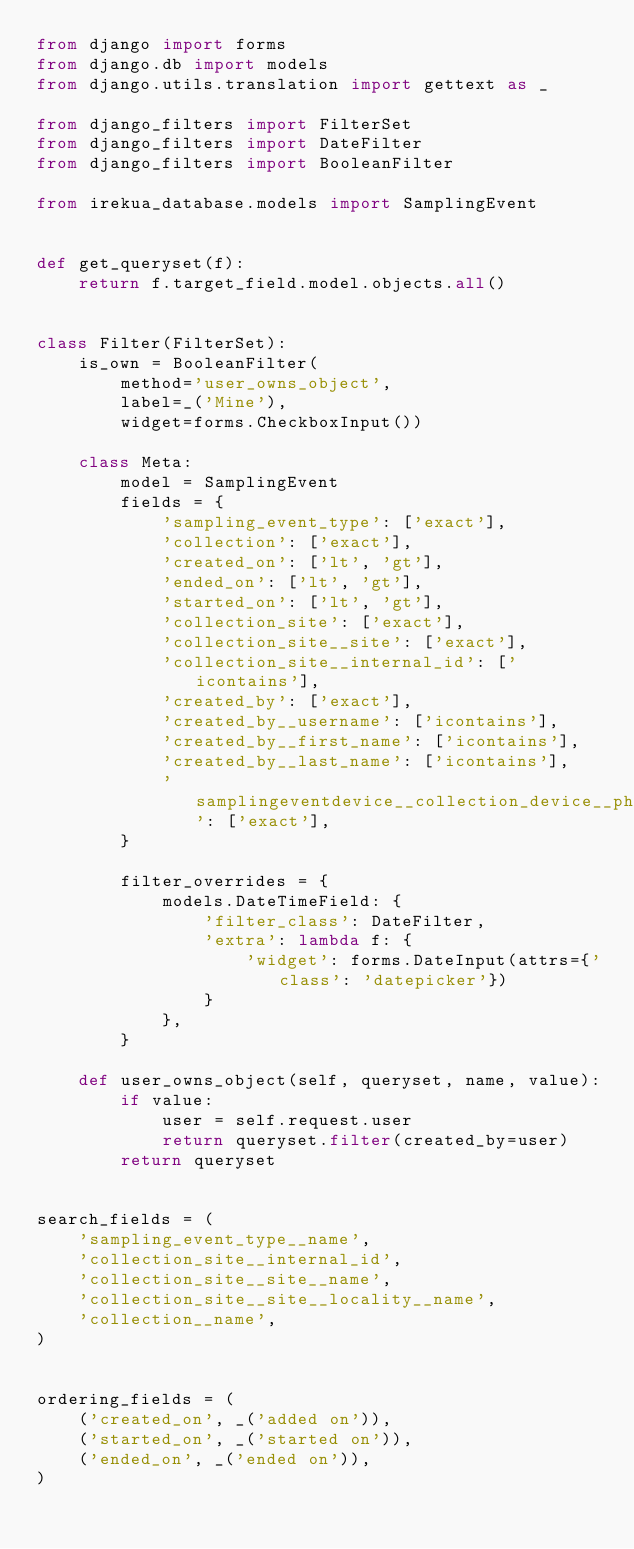Convert code to text. <code><loc_0><loc_0><loc_500><loc_500><_Python_>from django import forms
from django.db import models
from django.utils.translation import gettext as _

from django_filters import FilterSet
from django_filters import DateFilter
from django_filters import BooleanFilter

from irekua_database.models import SamplingEvent


def get_queryset(f):
    return f.target_field.model.objects.all()


class Filter(FilterSet):
    is_own = BooleanFilter(
        method='user_owns_object',
        label=_('Mine'),
        widget=forms.CheckboxInput())

    class Meta:
        model = SamplingEvent
        fields = {
            'sampling_event_type': ['exact'],
            'collection': ['exact'],
            'created_on': ['lt', 'gt'],
            'ended_on': ['lt', 'gt'],
            'started_on': ['lt', 'gt'],
            'collection_site': ['exact'],
            'collection_site__site': ['exact'],
            'collection_site__internal_id': ['icontains'],
            'created_by': ['exact'],
            'created_by__username': ['icontains'],
            'created_by__first_name': ['icontains'],
            'created_by__last_name': ['icontains'],
            'samplingeventdevice__collection_device__physical_device': ['exact'],
        }

        filter_overrides = {
            models.DateTimeField: {
                'filter_class': DateFilter,
                'extra': lambda f: {
                    'widget': forms.DateInput(attrs={'class': 'datepicker'})
                }
            },
        }

    def user_owns_object(self, queryset, name, value):
        if value:
            user = self.request.user
            return queryset.filter(created_by=user)
        return queryset


search_fields = (
    'sampling_event_type__name',
    'collection_site__internal_id',
    'collection_site__site__name',
    'collection_site__site__locality__name',
    'collection__name',
)


ordering_fields = (
    ('created_on', _('added on')),
    ('started_on', _('started on')),
    ('ended_on', _('ended on')),
)
</code> 